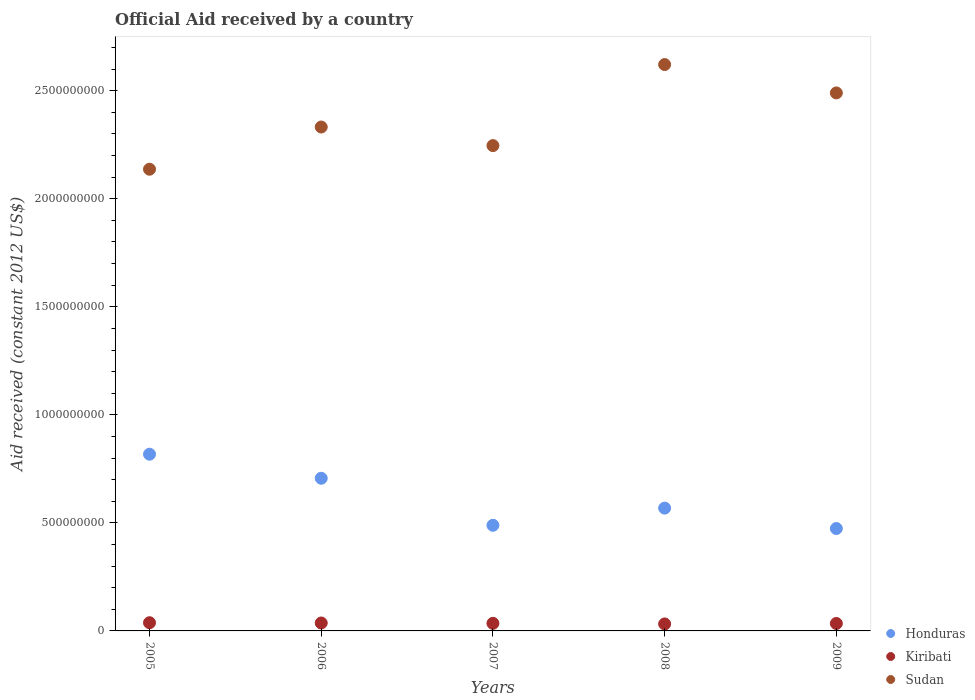What is the net official aid received in Kiribati in 2008?
Offer a terse response. 3.23e+07. Across all years, what is the maximum net official aid received in Sudan?
Keep it short and to the point. 2.62e+09. Across all years, what is the minimum net official aid received in Sudan?
Give a very brief answer. 2.14e+09. What is the total net official aid received in Kiribati in the graph?
Your response must be concise. 1.77e+08. What is the difference between the net official aid received in Sudan in 2005 and that in 2006?
Keep it short and to the point. -1.95e+08. What is the difference between the net official aid received in Honduras in 2007 and the net official aid received in Kiribati in 2008?
Make the answer very short. 4.57e+08. What is the average net official aid received in Kiribati per year?
Give a very brief answer. 3.53e+07. In the year 2005, what is the difference between the net official aid received in Kiribati and net official aid received in Sudan?
Your response must be concise. -2.10e+09. In how many years, is the net official aid received in Honduras greater than 200000000 US$?
Offer a very short reply. 5. What is the ratio of the net official aid received in Honduras in 2005 to that in 2008?
Provide a short and direct response. 1.44. What is the difference between the highest and the second highest net official aid received in Kiribati?
Provide a short and direct response. 1.26e+06. What is the difference between the highest and the lowest net official aid received in Kiribati?
Make the answer very short. 5.62e+06. Is the sum of the net official aid received in Honduras in 2005 and 2009 greater than the maximum net official aid received in Kiribati across all years?
Keep it short and to the point. Yes. Does the net official aid received in Honduras monotonically increase over the years?
Your response must be concise. No. Does the graph contain any zero values?
Your answer should be very brief. No. Where does the legend appear in the graph?
Give a very brief answer. Bottom right. How are the legend labels stacked?
Provide a succinct answer. Vertical. What is the title of the graph?
Provide a succinct answer. Official Aid received by a country. Does "Kosovo" appear as one of the legend labels in the graph?
Your answer should be very brief. No. What is the label or title of the X-axis?
Provide a succinct answer. Years. What is the label or title of the Y-axis?
Keep it short and to the point. Aid received (constant 2012 US$). What is the Aid received (constant 2012 US$) of Honduras in 2005?
Provide a succinct answer. 8.18e+08. What is the Aid received (constant 2012 US$) in Kiribati in 2005?
Offer a terse response. 3.80e+07. What is the Aid received (constant 2012 US$) of Sudan in 2005?
Your answer should be compact. 2.14e+09. What is the Aid received (constant 2012 US$) in Honduras in 2006?
Ensure brevity in your answer.  7.06e+08. What is the Aid received (constant 2012 US$) in Kiribati in 2006?
Your answer should be very brief. 3.67e+07. What is the Aid received (constant 2012 US$) in Sudan in 2006?
Offer a very short reply. 2.33e+09. What is the Aid received (constant 2012 US$) in Honduras in 2007?
Your answer should be very brief. 4.89e+08. What is the Aid received (constant 2012 US$) in Kiribati in 2007?
Give a very brief answer. 3.51e+07. What is the Aid received (constant 2012 US$) in Sudan in 2007?
Ensure brevity in your answer.  2.25e+09. What is the Aid received (constant 2012 US$) of Honduras in 2008?
Keep it short and to the point. 5.68e+08. What is the Aid received (constant 2012 US$) in Kiribati in 2008?
Make the answer very short. 3.23e+07. What is the Aid received (constant 2012 US$) in Sudan in 2008?
Your response must be concise. 2.62e+09. What is the Aid received (constant 2012 US$) in Honduras in 2009?
Make the answer very short. 4.74e+08. What is the Aid received (constant 2012 US$) of Kiribati in 2009?
Ensure brevity in your answer.  3.45e+07. What is the Aid received (constant 2012 US$) in Sudan in 2009?
Your answer should be very brief. 2.49e+09. Across all years, what is the maximum Aid received (constant 2012 US$) of Honduras?
Offer a terse response. 8.18e+08. Across all years, what is the maximum Aid received (constant 2012 US$) of Kiribati?
Make the answer very short. 3.80e+07. Across all years, what is the maximum Aid received (constant 2012 US$) of Sudan?
Make the answer very short. 2.62e+09. Across all years, what is the minimum Aid received (constant 2012 US$) of Honduras?
Make the answer very short. 4.74e+08. Across all years, what is the minimum Aid received (constant 2012 US$) of Kiribati?
Your answer should be very brief. 3.23e+07. Across all years, what is the minimum Aid received (constant 2012 US$) in Sudan?
Make the answer very short. 2.14e+09. What is the total Aid received (constant 2012 US$) in Honduras in the graph?
Keep it short and to the point. 3.06e+09. What is the total Aid received (constant 2012 US$) in Kiribati in the graph?
Give a very brief answer. 1.77e+08. What is the total Aid received (constant 2012 US$) in Sudan in the graph?
Your answer should be compact. 1.18e+1. What is the difference between the Aid received (constant 2012 US$) of Honduras in 2005 and that in 2006?
Provide a short and direct response. 1.11e+08. What is the difference between the Aid received (constant 2012 US$) of Kiribati in 2005 and that in 2006?
Provide a succinct answer. 1.26e+06. What is the difference between the Aid received (constant 2012 US$) in Sudan in 2005 and that in 2006?
Make the answer very short. -1.95e+08. What is the difference between the Aid received (constant 2012 US$) of Honduras in 2005 and that in 2007?
Give a very brief answer. 3.29e+08. What is the difference between the Aid received (constant 2012 US$) in Kiribati in 2005 and that in 2007?
Your response must be concise. 2.86e+06. What is the difference between the Aid received (constant 2012 US$) in Sudan in 2005 and that in 2007?
Offer a terse response. -1.09e+08. What is the difference between the Aid received (constant 2012 US$) in Honduras in 2005 and that in 2008?
Offer a terse response. 2.49e+08. What is the difference between the Aid received (constant 2012 US$) of Kiribati in 2005 and that in 2008?
Your answer should be compact. 5.62e+06. What is the difference between the Aid received (constant 2012 US$) in Sudan in 2005 and that in 2008?
Your answer should be compact. -4.84e+08. What is the difference between the Aid received (constant 2012 US$) of Honduras in 2005 and that in 2009?
Ensure brevity in your answer.  3.44e+08. What is the difference between the Aid received (constant 2012 US$) of Kiribati in 2005 and that in 2009?
Make the answer very short. 3.49e+06. What is the difference between the Aid received (constant 2012 US$) of Sudan in 2005 and that in 2009?
Your answer should be very brief. -3.53e+08. What is the difference between the Aid received (constant 2012 US$) of Honduras in 2006 and that in 2007?
Your answer should be compact. 2.18e+08. What is the difference between the Aid received (constant 2012 US$) in Kiribati in 2006 and that in 2007?
Offer a terse response. 1.60e+06. What is the difference between the Aid received (constant 2012 US$) in Sudan in 2006 and that in 2007?
Offer a very short reply. 8.60e+07. What is the difference between the Aid received (constant 2012 US$) of Honduras in 2006 and that in 2008?
Ensure brevity in your answer.  1.38e+08. What is the difference between the Aid received (constant 2012 US$) of Kiribati in 2006 and that in 2008?
Offer a terse response. 4.36e+06. What is the difference between the Aid received (constant 2012 US$) in Sudan in 2006 and that in 2008?
Give a very brief answer. -2.89e+08. What is the difference between the Aid received (constant 2012 US$) of Honduras in 2006 and that in 2009?
Provide a short and direct response. 2.33e+08. What is the difference between the Aid received (constant 2012 US$) in Kiribati in 2006 and that in 2009?
Your answer should be very brief. 2.23e+06. What is the difference between the Aid received (constant 2012 US$) of Sudan in 2006 and that in 2009?
Give a very brief answer. -1.58e+08. What is the difference between the Aid received (constant 2012 US$) of Honduras in 2007 and that in 2008?
Offer a terse response. -7.95e+07. What is the difference between the Aid received (constant 2012 US$) in Kiribati in 2007 and that in 2008?
Ensure brevity in your answer.  2.76e+06. What is the difference between the Aid received (constant 2012 US$) in Sudan in 2007 and that in 2008?
Your answer should be very brief. -3.75e+08. What is the difference between the Aid received (constant 2012 US$) of Honduras in 2007 and that in 2009?
Your response must be concise. 1.50e+07. What is the difference between the Aid received (constant 2012 US$) of Kiribati in 2007 and that in 2009?
Your answer should be compact. 6.30e+05. What is the difference between the Aid received (constant 2012 US$) of Sudan in 2007 and that in 2009?
Ensure brevity in your answer.  -2.44e+08. What is the difference between the Aid received (constant 2012 US$) of Honduras in 2008 and that in 2009?
Your answer should be very brief. 9.45e+07. What is the difference between the Aid received (constant 2012 US$) of Kiribati in 2008 and that in 2009?
Your response must be concise. -2.13e+06. What is the difference between the Aid received (constant 2012 US$) of Sudan in 2008 and that in 2009?
Make the answer very short. 1.31e+08. What is the difference between the Aid received (constant 2012 US$) in Honduras in 2005 and the Aid received (constant 2012 US$) in Kiribati in 2006?
Your answer should be very brief. 7.81e+08. What is the difference between the Aid received (constant 2012 US$) in Honduras in 2005 and the Aid received (constant 2012 US$) in Sudan in 2006?
Keep it short and to the point. -1.51e+09. What is the difference between the Aid received (constant 2012 US$) in Kiribati in 2005 and the Aid received (constant 2012 US$) in Sudan in 2006?
Offer a very short reply. -2.29e+09. What is the difference between the Aid received (constant 2012 US$) of Honduras in 2005 and the Aid received (constant 2012 US$) of Kiribati in 2007?
Make the answer very short. 7.83e+08. What is the difference between the Aid received (constant 2012 US$) of Honduras in 2005 and the Aid received (constant 2012 US$) of Sudan in 2007?
Provide a succinct answer. -1.43e+09. What is the difference between the Aid received (constant 2012 US$) in Kiribati in 2005 and the Aid received (constant 2012 US$) in Sudan in 2007?
Keep it short and to the point. -2.21e+09. What is the difference between the Aid received (constant 2012 US$) in Honduras in 2005 and the Aid received (constant 2012 US$) in Kiribati in 2008?
Make the answer very short. 7.85e+08. What is the difference between the Aid received (constant 2012 US$) of Honduras in 2005 and the Aid received (constant 2012 US$) of Sudan in 2008?
Provide a short and direct response. -1.80e+09. What is the difference between the Aid received (constant 2012 US$) of Kiribati in 2005 and the Aid received (constant 2012 US$) of Sudan in 2008?
Offer a very short reply. -2.58e+09. What is the difference between the Aid received (constant 2012 US$) in Honduras in 2005 and the Aid received (constant 2012 US$) in Kiribati in 2009?
Give a very brief answer. 7.83e+08. What is the difference between the Aid received (constant 2012 US$) of Honduras in 2005 and the Aid received (constant 2012 US$) of Sudan in 2009?
Offer a very short reply. -1.67e+09. What is the difference between the Aid received (constant 2012 US$) of Kiribati in 2005 and the Aid received (constant 2012 US$) of Sudan in 2009?
Offer a terse response. -2.45e+09. What is the difference between the Aid received (constant 2012 US$) in Honduras in 2006 and the Aid received (constant 2012 US$) in Kiribati in 2007?
Offer a terse response. 6.71e+08. What is the difference between the Aid received (constant 2012 US$) in Honduras in 2006 and the Aid received (constant 2012 US$) in Sudan in 2007?
Give a very brief answer. -1.54e+09. What is the difference between the Aid received (constant 2012 US$) in Kiribati in 2006 and the Aid received (constant 2012 US$) in Sudan in 2007?
Ensure brevity in your answer.  -2.21e+09. What is the difference between the Aid received (constant 2012 US$) of Honduras in 2006 and the Aid received (constant 2012 US$) of Kiribati in 2008?
Provide a succinct answer. 6.74e+08. What is the difference between the Aid received (constant 2012 US$) of Honduras in 2006 and the Aid received (constant 2012 US$) of Sudan in 2008?
Ensure brevity in your answer.  -1.91e+09. What is the difference between the Aid received (constant 2012 US$) in Kiribati in 2006 and the Aid received (constant 2012 US$) in Sudan in 2008?
Ensure brevity in your answer.  -2.58e+09. What is the difference between the Aid received (constant 2012 US$) of Honduras in 2006 and the Aid received (constant 2012 US$) of Kiribati in 2009?
Ensure brevity in your answer.  6.72e+08. What is the difference between the Aid received (constant 2012 US$) in Honduras in 2006 and the Aid received (constant 2012 US$) in Sudan in 2009?
Offer a terse response. -1.78e+09. What is the difference between the Aid received (constant 2012 US$) in Kiribati in 2006 and the Aid received (constant 2012 US$) in Sudan in 2009?
Make the answer very short. -2.45e+09. What is the difference between the Aid received (constant 2012 US$) of Honduras in 2007 and the Aid received (constant 2012 US$) of Kiribati in 2008?
Ensure brevity in your answer.  4.57e+08. What is the difference between the Aid received (constant 2012 US$) of Honduras in 2007 and the Aid received (constant 2012 US$) of Sudan in 2008?
Keep it short and to the point. -2.13e+09. What is the difference between the Aid received (constant 2012 US$) in Kiribati in 2007 and the Aid received (constant 2012 US$) in Sudan in 2008?
Offer a very short reply. -2.59e+09. What is the difference between the Aid received (constant 2012 US$) in Honduras in 2007 and the Aid received (constant 2012 US$) in Kiribati in 2009?
Provide a short and direct response. 4.54e+08. What is the difference between the Aid received (constant 2012 US$) of Honduras in 2007 and the Aid received (constant 2012 US$) of Sudan in 2009?
Offer a very short reply. -2.00e+09. What is the difference between the Aid received (constant 2012 US$) of Kiribati in 2007 and the Aid received (constant 2012 US$) of Sudan in 2009?
Provide a short and direct response. -2.45e+09. What is the difference between the Aid received (constant 2012 US$) of Honduras in 2008 and the Aid received (constant 2012 US$) of Kiribati in 2009?
Keep it short and to the point. 5.34e+08. What is the difference between the Aid received (constant 2012 US$) of Honduras in 2008 and the Aid received (constant 2012 US$) of Sudan in 2009?
Your answer should be very brief. -1.92e+09. What is the difference between the Aid received (constant 2012 US$) in Kiribati in 2008 and the Aid received (constant 2012 US$) in Sudan in 2009?
Provide a succinct answer. -2.46e+09. What is the average Aid received (constant 2012 US$) of Honduras per year?
Your answer should be compact. 6.11e+08. What is the average Aid received (constant 2012 US$) in Kiribati per year?
Your response must be concise. 3.53e+07. What is the average Aid received (constant 2012 US$) in Sudan per year?
Give a very brief answer. 2.37e+09. In the year 2005, what is the difference between the Aid received (constant 2012 US$) of Honduras and Aid received (constant 2012 US$) of Kiribati?
Give a very brief answer. 7.80e+08. In the year 2005, what is the difference between the Aid received (constant 2012 US$) in Honduras and Aid received (constant 2012 US$) in Sudan?
Keep it short and to the point. -1.32e+09. In the year 2005, what is the difference between the Aid received (constant 2012 US$) of Kiribati and Aid received (constant 2012 US$) of Sudan?
Provide a short and direct response. -2.10e+09. In the year 2006, what is the difference between the Aid received (constant 2012 US$) in Honduras and Aid received (constant 2012 US$) in Kiribati?
Offer a very short reply. 6.70e+08. In the year 2006, what is the difference between the Aid received (constant 2012 US$) of Honduras and Aid received (constant 2012 US$) of Sudan?
Provide a succinct answer. -1.63e+09. In the year 2006, what is the difference between the Aid received (constant 2012 US$) in Kiribati and Aid received (constant 2012 US$) in Sudan?
Your answer should be compact. -2.30e+09. In the year 2007, what is the difference between the Aid received (constant 2012 US$) of Honduras and Aid received (constant 2012 US$) of Kiribati?
Your response must be concise. 4.54e+08. In the year 2007, what is the difference between the Aid received (constant 2012 US$) in Honduras and Aid received (constant 2012 US$) in Sudan?
Provide a succinct answer. -1.76e+09. In the year 2007, what is the difference between the Aid received (constant 2012 US$) of Kiribati and Aid received (constant 2012 US$) of Sudan?
Provide a succinct answer. -2.21e+09. In the year 2008, what is the difference between the Aid received (constant 2012 US$) of Honduras and Aid received (constant 2012 US$) of Kiribati?
Provide a succinct answer. 5.36e+08. In the year 2008, what is the difference between the Aid received (constant 2012 US$) in Honduras and Aid received (constant 2012 US$) in Sudan?
Offer a terse response. -2.05e+09. In the year 2008, what is the difference between the Aid received (constant 2012 US$) in Kiribati and Aid received (constant 2012 US$) in Sudan?
Your answer should be very brief. -2.59e+09. In the year 2009, what is the difference between the Aid received (constant 2012 US$) of Honduras and Aid received (constant 2012 US$) of Kiribati?
Keep it short and to the point. 4.39e+08. In the year 2009, what is the difference between the Aid received (constant 2012 US$) of Honduras and Aid received (constant 2012 US$) of Sudan?
Offer a very short reply. -2.02e+09. In the year 2009, what is the difference between the Aid received (constant 2012 US$) of Kiribati and Aid received (constant 2012 US$) of Sudan?
Keep it short and to the point. -2.46e+09. What is the ratio of the Aid received (constant 2012 US$) in Honduras in 2005 to that in 2006?
Ensure brevity in your answer.  1.16. What is the ratio of the Aid received (constant 2012 US$) in Kiribati in 2005 to that in 2006?
Give a very brief answer. 1.03. What is the ratio of the Aid received (constant 2012 US$) in Sudan in 2005 to that in 2006?
Your answer should be compact. 0.92. What is the ratio of the Aid received (constant 2012 US$) of Honduras in 2005 to that in 2007?
Your answer should be very brief. 1.67. What is the ratio of the Aid received (constant 2012 US$) of Kiribati in 2005 to that in 2007?
Make the answer very short. 1.08. What is the ratio of the Aid received (constant 2012 US$) of Sudan in 2005 to that in 2007?
Your response must be concise. 0.95. What is the ratio of the Aid received (constant 2012 US$) of Honduras in 2005 to that in 2008?
Keep it short and to the point. 1.44. What is the ratio of the Aid received (constant 2012 US$) of Kiribati in 2005 to that in 2008?
Give a very brief answer. 1.17. What is the ratio of the Aid received (constant 2012 US$) in Sudan in 2005 to that in 2008?
Your response must be concise. 0.82. What is the ratio of the Aid received (constant 2012 US$) in Honduras in 2005 to that in 2009?
Offer a terse response. 1.73. What is the ratio of the Aid received (constant 2012 US$) of Kiribati in 2005 to that in 2009?
Offer a terse response. 1.1. What is the ratio of the Aid received (constant 2012 US$) in Sudan in 2005 to that in 2009?
Offer a terse response. 0.86. What is the ratio of the Aid received (constant 2012 US$) of Honduras in 2006 to that in 2007?
Offer a very short reply. 1.45. What is the ratio of the Aid received (constant 2012 US$) in Kiribati in 2006 to that in 2007?
Provide a succinct answer. 1.05. What is the ratio of the Aid received (constant 2012 US$) in Sudan in 2006 to that in 2007?
Provide a succinct answer. 1.04. What is the ratio of the Aid received (constant 2012 US$) of Honduras in 2006 to that in 2008?
Provide a short and direct response. 1.24. What is the ratio of the Aid received (constant 2012 US$) of Kiribati in 2006 to that in 2008?
Provide a succinct answer. 1.13. What is the ratio of the Aid received (constant 2012 US$) in Sudan in 2006 to that in 2008?
Offer a terse response. 0.89. What is the ratio of the Aid received (constant 2012 US$) in Honduras in 2006 to that in 2009?
Keep it short and to the point. 1.49. What is the ratio of the Aid received (constant 2012 US$) of Kiribati in 2006 to that in 2009?
Your response must be concise. 1.06. What is the ratio of the Aid received (constant 2012 US$) of Sudan in 2006 to that in 2009?
Provide a short and direct response. 0.94. What is the ratio of the Aid received (constant 2012 US$) in Honduras in 2007 to that in 2008?
Provide a succinct answer. 0.86. What is the ratio of the Aid received (constant 2012 US$) in Kiribati in 2007 to that in 2008?
Your answer should be very brief. 1.09. What is the ratio of the Aid received (constant 2012 US$) of Sudan in 2007 to that in 2008?
Offer a terse response. 0.86. What is the ratio of the Aid received (constant 2012 US$) in Honduras in 2007 to that in 2009?
Ensure brevity in your answer.  1.03. What is the ratio of the Aid received (constant 2012 US$) in Kiribati in 2007 to that in 2009?
Your answer should be very brief. 1.02. What is the ratio of the Aid received (constant 2012 US$) of Sudan in 2007 to that in 2009?
Ensure brevity in your answer.  0.9. What is the ratio of the Aid received (constant 2012 US$) of Honduras in 2008 to that in 2009?
Offer a very short reply. 1.2. What is the ratio of the Aid received (constant 2012 US$) of Kiribati in 2008 to that in 2009?
Your answer should be compact. 0.94. What is the ratio of the Aid received (constant 2012 US$) in Sudan in 2008 to that in 2009?
Provide a short and direct response. 1.05. What is the difference between the highest and the second highest Aid received (constant 2012 US$) of Honduras?
Ensure brevity in your answer.  1.11e+08. What is the difference between the highest and the second highest Aid received (constant 2012 US$) in Kiribati?
Give a very brief answer. 1.26e+06. What is the difference between the highest and the second highest Aid received (constant 2012 US$) in Sudan?
Provide a short and direct response. 1.31e+08. What is the difference between the highest and the lowest Aid received (constant 2012 US$) of Honduras?
Offer a terse response. 3.44e+08. What is the difference between the highest and the lowest Aid received (constant 2012 US$) of Kiribati?
Your response must be concise. 5.62e+06. What is the difference between the highest and the lowest Aid received (constant 2012 US$) of Sudan?
Offer a very short reply. 4.84e+08. 